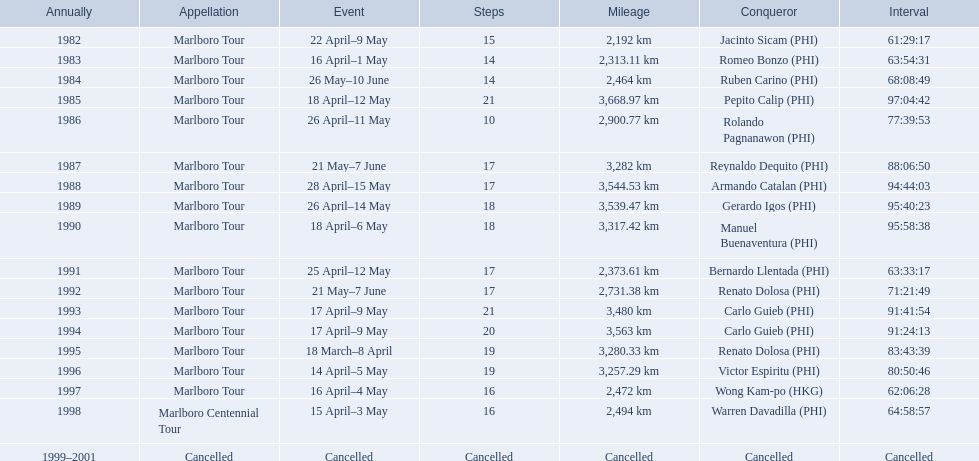What are the distances travelled on the tour? 2,192 km, 2,313.11 km, 2,464 km, 3,668.97 km, 2,900.77 km, 3,282 km, 3,544.53 km, 3,539.47 km, 3,317.42 km, 2,373.61 km, 2,731.38 km, 3,480 km, 3,563 km, 3,280.33 km, 3,257.29 km, 2,472 km, 2,494 km. Which of these are the largest? 3,668.97 km. 